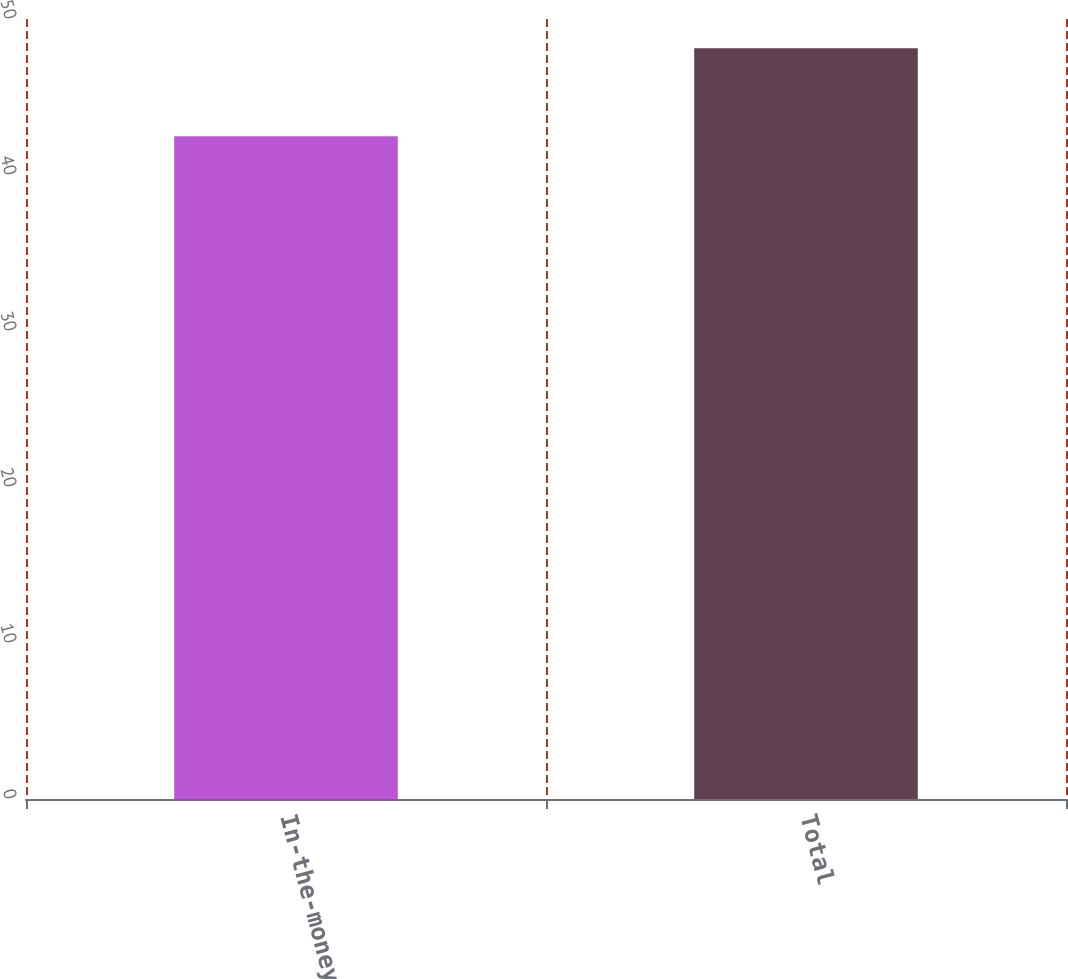<chart> <loc_0><loc_0><loc_500><loc_500><bar_chart><fcel>In-the-money<fcel>Total<nl><fcel>42.49<fcel>48.12<nl></chart> 